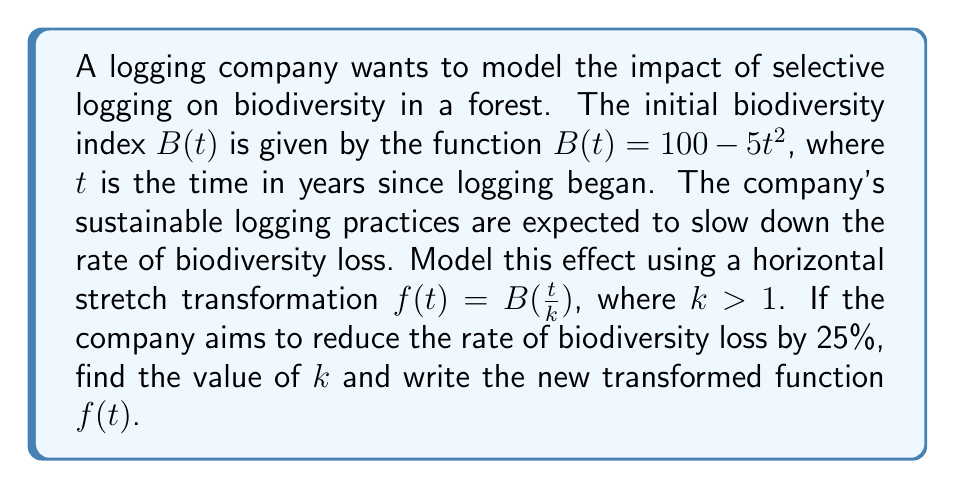Give your solution to this math problem. To solve this problem, we'll follow these steps:

1) The original function is $B(t) = 100 - 5t^2$.

2) We're applying a horizontal stretch transformation: $f(t) = B(\frac{t}{k})$, where $k > 1$.

3) Substituting the original function into the transformation:

   $f(t) = 100 - 5(\frac{t}{k})^2$

4) The company wants to reduce the rate of biodiversity loss by 25%. This means the new rate should be 75% of the original rate.

5) In the original function, the rate of change is determined by the coefficient of $t^2$, which is -5.

6) In the transformed function, this coefficient becomes $-5(\frac{1}{k})^2$ or $-\frac{5}{k^2}$.

7) For this to be 75% of the original rate:

   $-\frac{5}{k^2} = 0.75(-5)$

8) Solving for $k$:

   $\frac{5}{k^2} = 3.75$
   $k^2 = \frac{5}{3.75} = \frac{4}{3}$
   $k = \sqrt{\frac{4}{3}} \approx 1.1547$

9) Now we can write the transformed function by substituting this value of $k$:

   $f(t) = 100 - 5(\frac{t}{\sqrt{\frac{4}{3}}})^2$

   Or simplified:

   $f(t) = 100 - \frac{15t^2}{4}$
Answer: $k = \sqrt{\frac{4}{3}} \approx 1.1547$
$f(t) = 100 - \frac{15t^2}{4}$ 